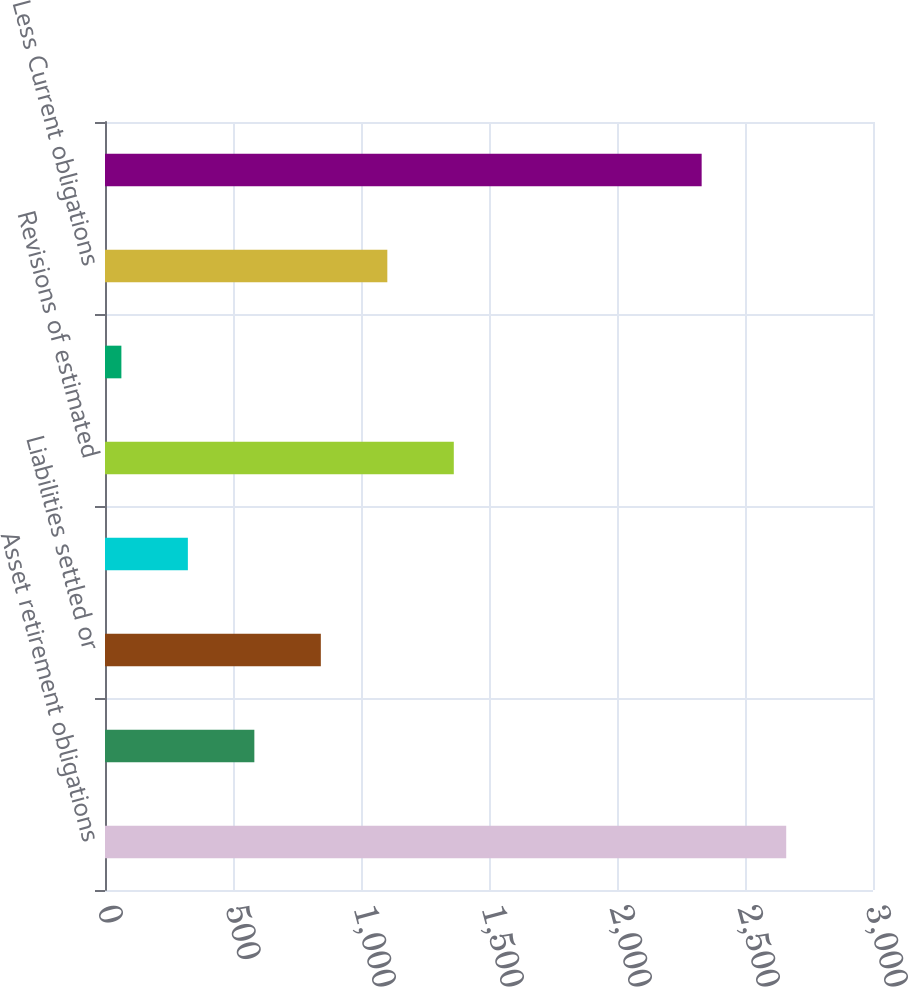Convert chart. <chart><loc_0><loc_0><loc_500><loc_500><bar_chart><fcel>Asset retirement obligations<fcel>Liabilities incurred<fcel>Liabilities settled or<fcel>Accretion expense<fcel>Revisions of estimated<fcel>Foreign currency translation<fcel>Less Current obligations<fcel>Long-term obligations at<nl><fcel>2661<fcel>583.4<fcel>843.1<fcel>323.7<fcel>1362.5<fcel>64<fcel>1102.8<fcel>2330.7<nl></chart> 